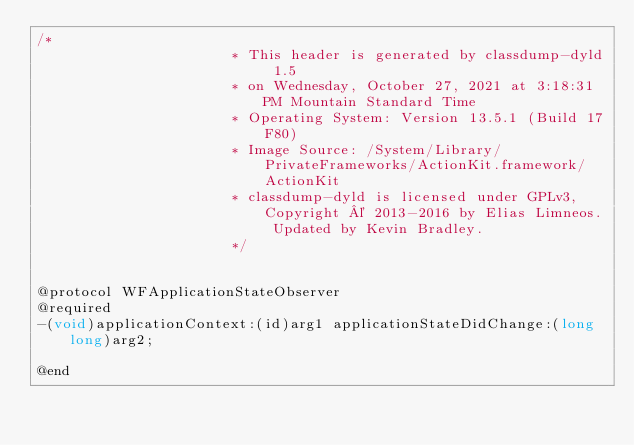<code> <loc_0><loc_0><loc_500><loc_500><_C_>/*
                       * This header is generated by classdump-dyld 1.5
                       * on Wednesday, October 27, 2021 at 3:18:31 PM Mountain Standard Time
                       * Operating System: Version 13.5.1 (Build 17F80)
                       * Image Source: /System/Library/PrivateFrameworks/ActionKit.framework/ActionKit
                       * classdump-dyld is licensed under GPLv3, Copyright © 2013-2016 by Elias Limneos. Updated by Kevin Bradley.
                       */


@protocol WFApplicationStateObserver
@required
-(void)applicationContext:(id)arg1 applicationStateDidChange:(long long)arg2;

@end

</code> 